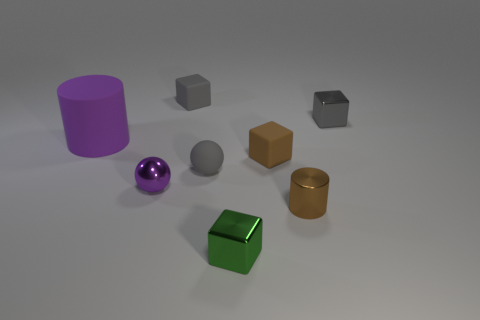Is there any object in the image that stands out due to its color? The purple cylinder stands out because of its vibrant color, which contrasts with the more subdued tones of the other objects in the image. 